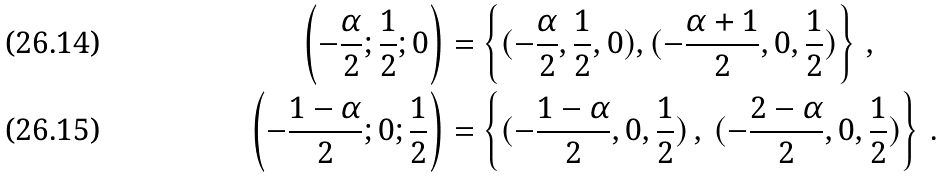<formula> <loc_0><loc_0><loc_500><loc_500>\left ( - \frac { \alpha } { 2 } ; \frac { 1 } { 2 } ; 0 \right ) & = \left \{ ( - \frac { \alpha } { 2 } , \frac { 1 } { 2 } , 0 ) , ( - \frac { \alpha + 1 } { 2 } , 0 , \frac { 1 } { 2 } ) \right \} \, , \\ \left ( - \frac { 1 - \alpha } { 2 } ; 0 ; \frac { 1 } { 2 } \right ) & = \left \{ ( - \frac { 1 - \alpha } { 2 } , 0 , \frac { 1 } { 2 } ) \, , \, ( - \frac { 2 - \alpha } { 2 } , 0 , \frac { 1 } { 2 } ) \right \} \, .</formula> 